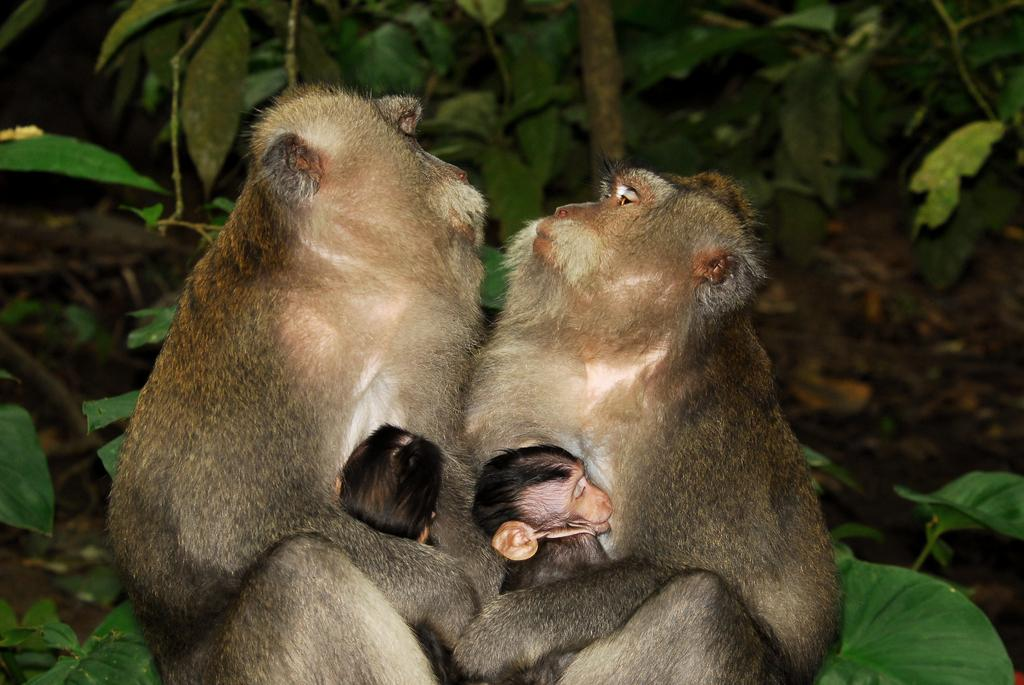How many monkeys are in the image? There are two monkeys in the image. What are the monkeys doing in the image? The monkeys are sitting and holding their babies in their hands. What can be seen in the background of the image? There are plants and the ground visible in the background of the image. What type of polish is the monkey using to shine its fur in the image? There is no polish or any indication of the monkeys shining their fur in the image. 